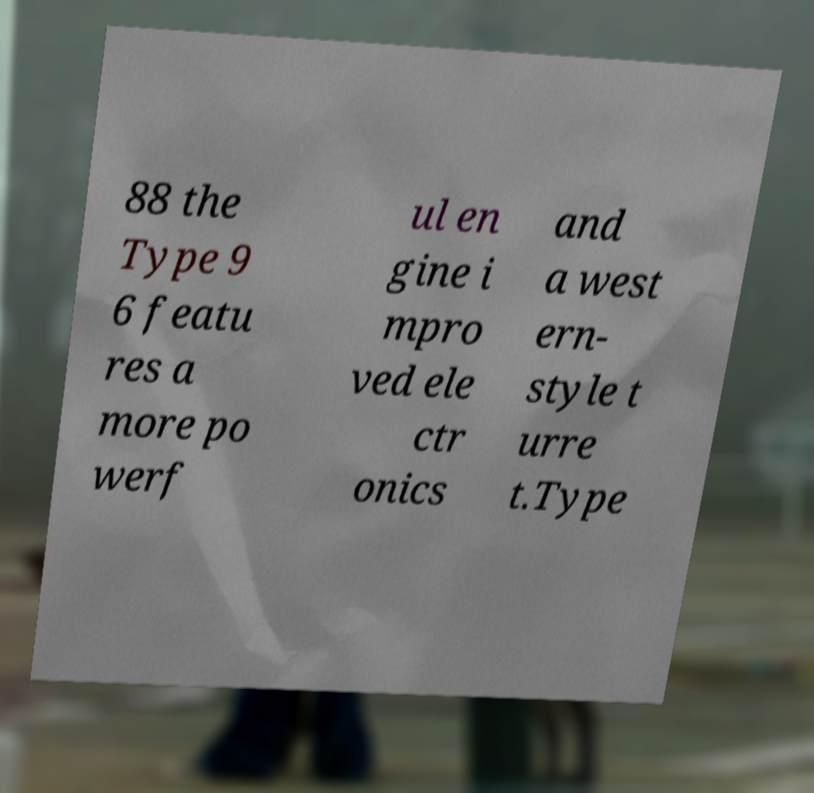What messages or text are displayed in this image? I need them in a readable, typed format. 88 the Type 9 6 featu res a more po werf ul en gine i mpro ved ele ctr onics and a west ern- style t urre t.Type 